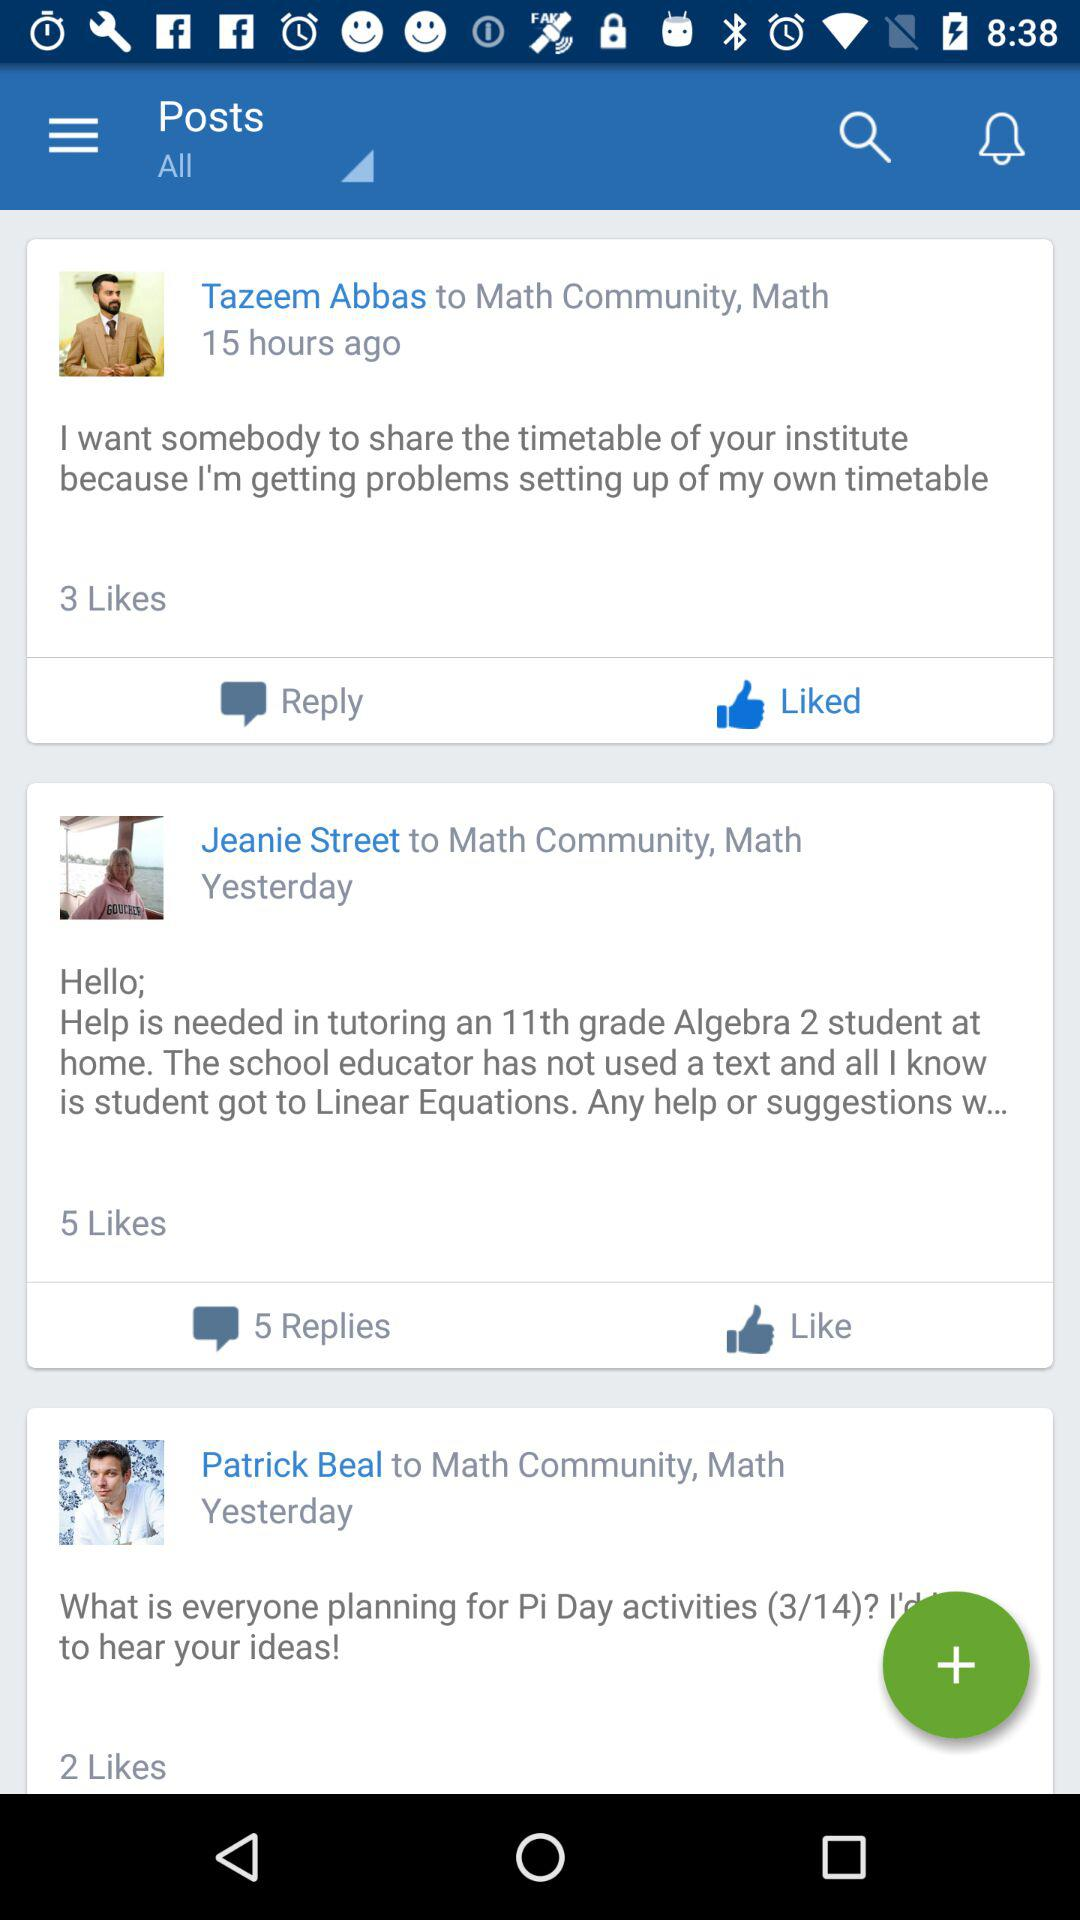How many posts are there in the Math Community?
Answer the question using a single word or phrase. 3 